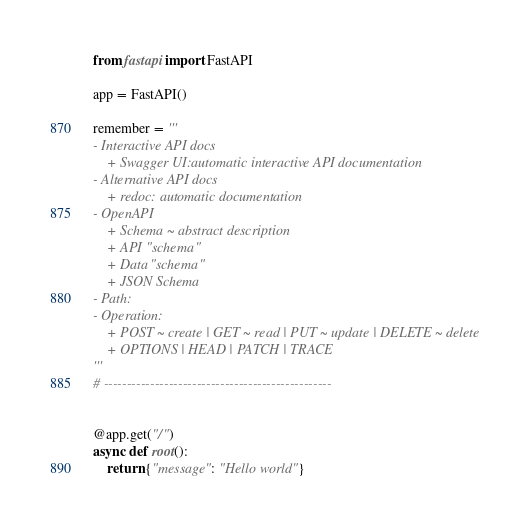<code> <loc_0><loc_0><loc_500><loc_500><_Python_>from fastapi import FastAPI

app = FastAPI()

remember = '''
- Interactive API docs
    + Swagger UI:automatic interactive API documentation
- Alternative API docs
    + redoc: automatic documentation
- OpenAPI
    + Schema ~ abstract description
    + API "schema"
    + Data "schema"
    + JSON Schema
- Path:
- Operation: 
    + POST ~ create | GET ~ read | PUT ~ update | DELETE ~ delete 
    + OPTIONS | HEAD | PATCH | TRACE
'''
# -------------------------------------------------


@app.get("/")
async def root():
    return {"message": "Hello world"}
</code> 